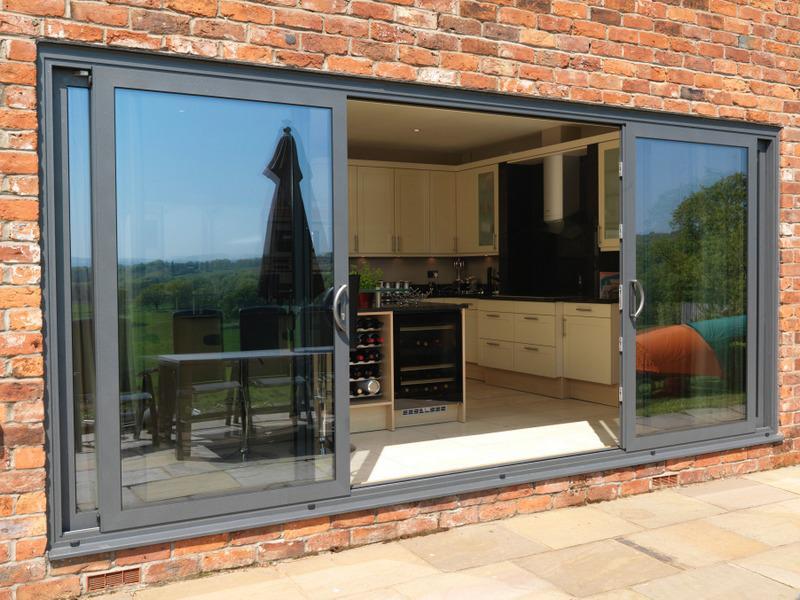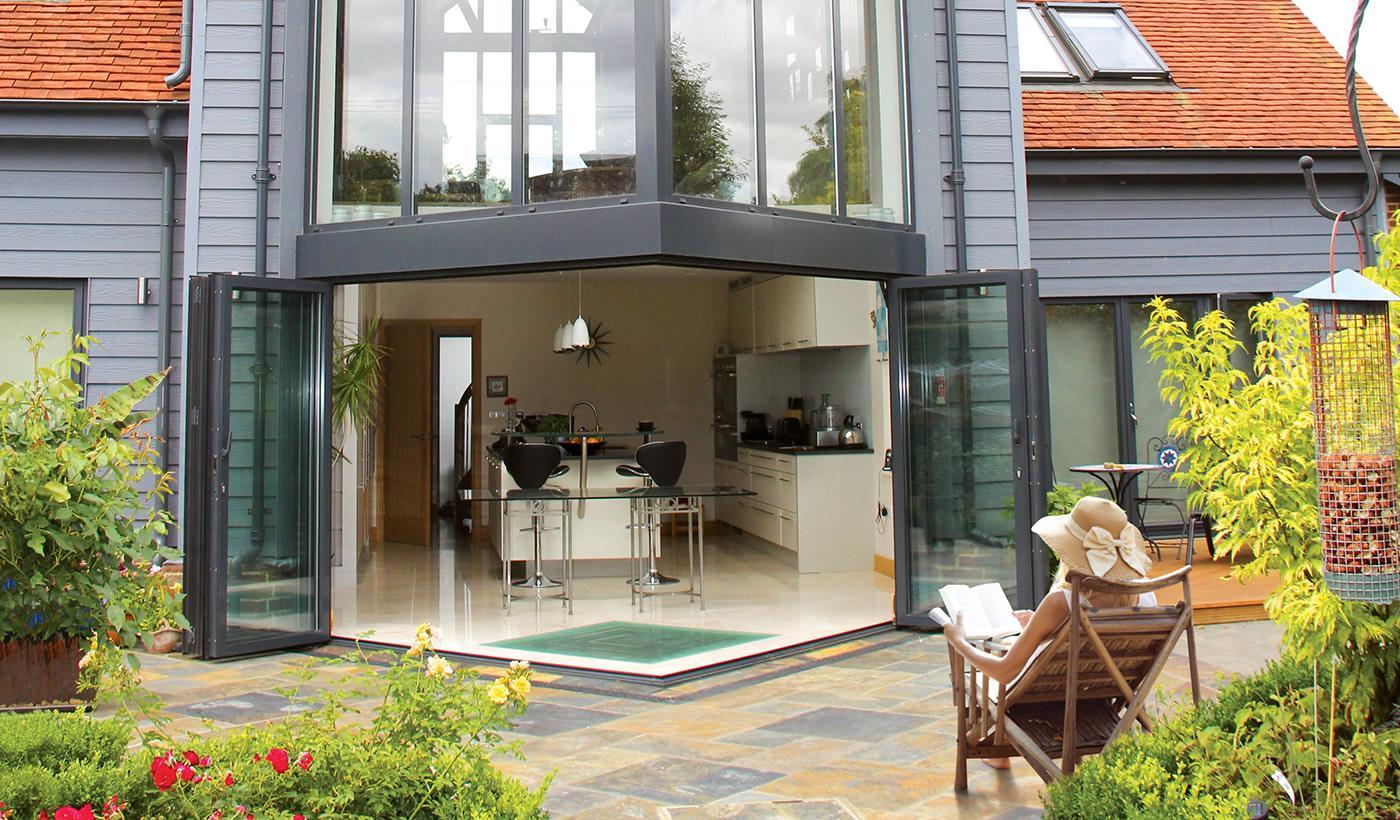The first image is the image on the left, the second image is the image on the right. Considering the images on both sides, is "An image shows a brick wall with one multi-door sliding glass element that is open in the center, revealing a room of furniture." valid? Answer yes or no. Yes. 